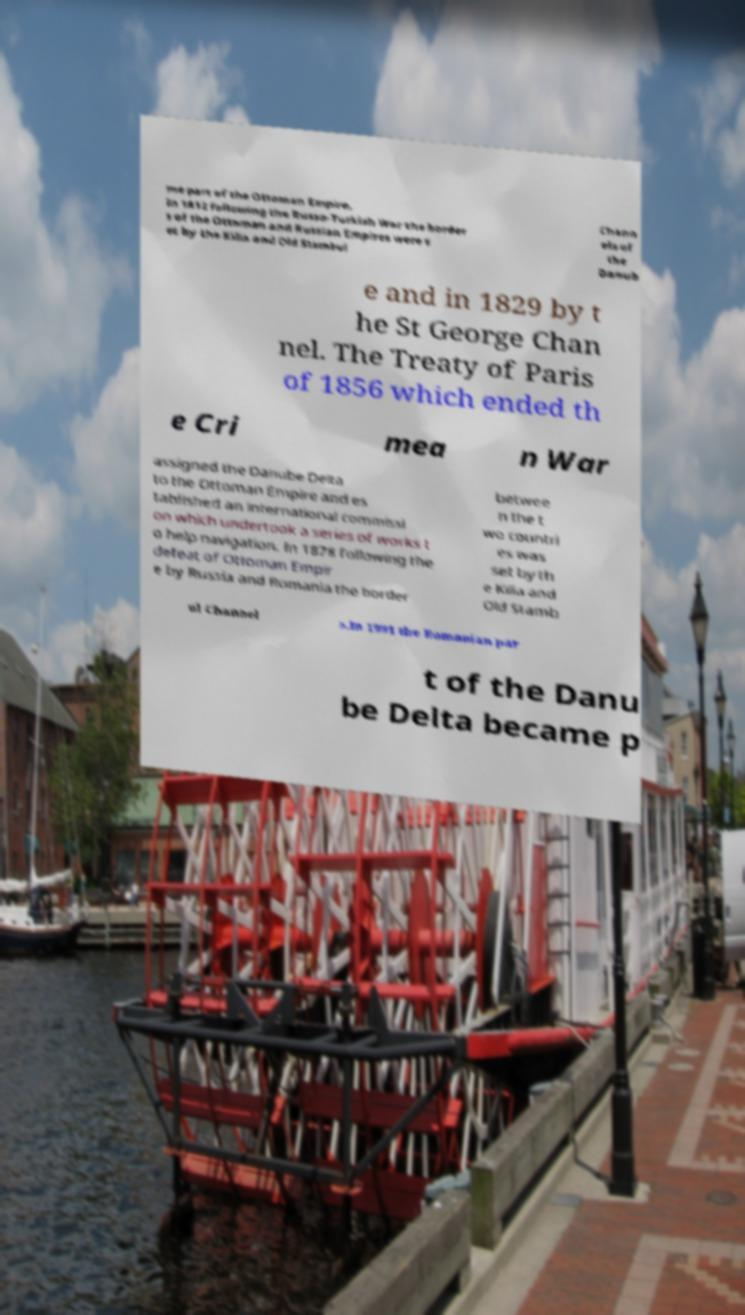Please read and relay the text visible in this image. What does it say? me part of the Ottoman Empire. In 1812 following the Russo-Turkish War the border s of the Ottoman and Russian Empires were s et by the Kilia and Old Stambul Chann els of the Danub e and in 1829 by t he St George Chan nel. The Treaty of Paris of 1856 which ended th e Cri mea n War assigned the Danube Delta to the Ottoman Empire and es tablished an international commissi on which undertook a series of works t o help navigation. In 1878 following the defeat of Ottoman Empir e by Russia and Romania the border betwee n the t wo countri es was set by th e Kilia and Old Stamb ul Channel s.In 1991 the Romanian par t of the Danu be Delta became p 